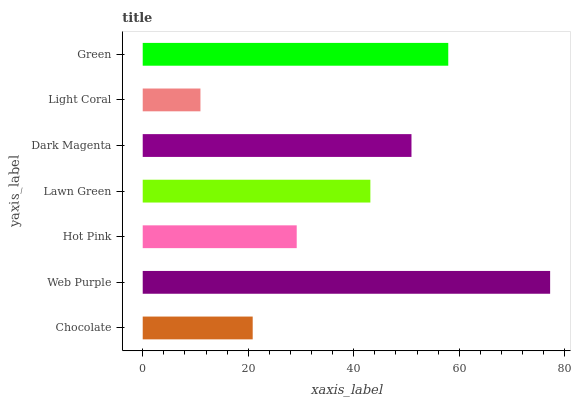Is Light Coral the minimum?
Answer yes or no. Yes. Is Web Purple the maximum?
Answer yes or no. Yes. Is Hot Pink the minimum?
Answer yes or no. No. Is Hot Pink the maximum?
Answer yes or no. No. Is Web Purple greater than Hot Pink?
Answer yes or no. Yes. Is Hot Pink less than Web Purple?
Answer yes or no. Yes. Is Hot Pink greater than Web Purple?
Answer yes or no. No. Is Web Purple less than Hot Pink?
Answer yes or no. No. Is Lawn Green the high median?
Answer yes or no. Yes. Is Lawn Green the low median?
Answer yes or no. Yes. Is Dark Magenta the high median?
Answer yes or no. No. Is Chocolate the low median?
Answer yes or no. No. 